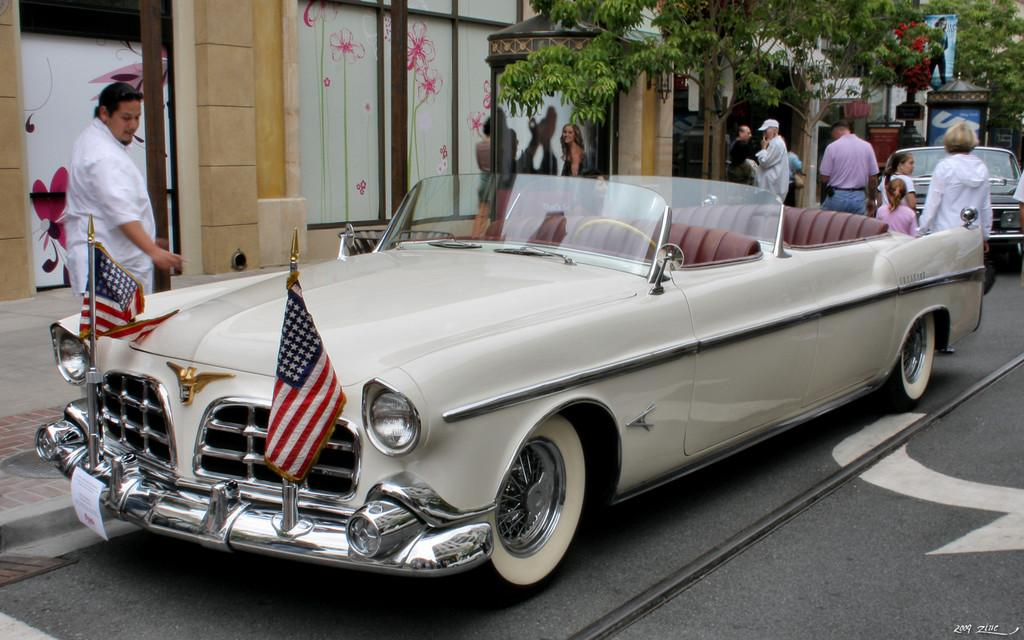What can be seen on the road in the image? There are persons and cars on the road in the image. What is visible in the background of the image? There are buildings, trees, and hoardings in the background. What type of church can be seen in the image? There is no church present in the image. What is the cook doing in the image? There is no cook present in the image. 